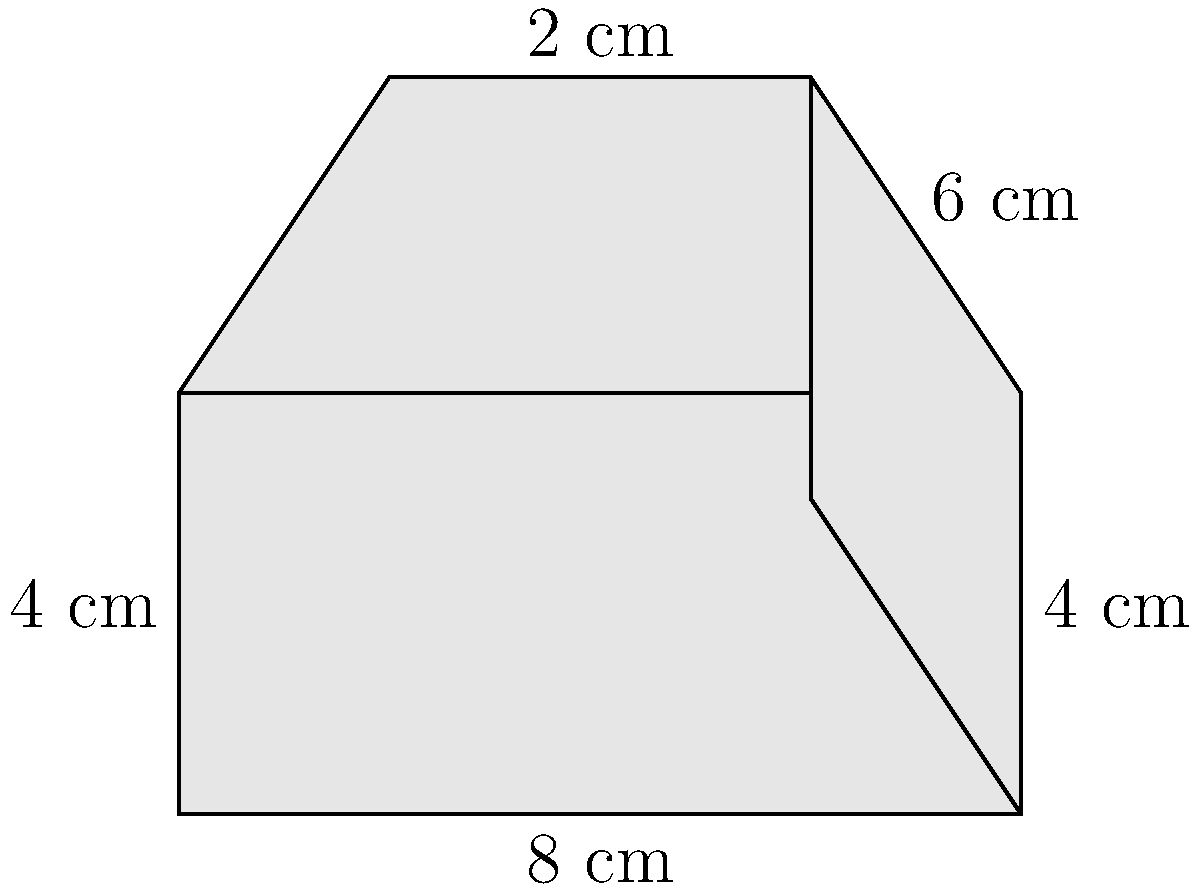You're designing a custom amplifier for your next world tour. The amplifier has an irregular shape as shown in the diagram. The base is a rectangle measuring 8 cm by 4 cm. The top face is a trapezoid with parallel sides of 8 cm and 4 cm, and a height of 3 cm. The front and back are rectangles, while the sides are irregular quadrilaterals. Calculate the total surface area of the amplifier in square centimeters. Let's break this down step-by-step:

1) Base area: 
   $$A_{base} = 8 \times 4 = 32 \text{ cm}^2$$

2) Top area (trapezoid):
   $$A_{top} = \frac{1}{2}(8 + 4) \times 3 = 18 \text{ cm}^2$$

3) Front and back areas (rectangles):
   $$A_{front} = A_{back} = 8 \times 4 = 32 \text{ cm}^2 \text{ each}$$
   $$A_{front+back} = 2 \times 32 = 64 \text{ cm}^2$$

4) Side areas (irregular quadrilaterals):
   We can split each side into a rectangle and a right triangle.
   Rectangle: $4 \times 4 = 16 \text{ cm}^2$
   Triangle: $\frac{1}{2} \times 2 \times 3 = 3 \text{ cm}^2$
   $$A_{oneside} = 16 + 3 = 19 \text{ cm}^2$$
   $$A_{bothsides} = 2 \times 19 = 38 \text{ cm}^2$$

5) Total surface area:
   $$A_{total} = A_{base} + A_{top} + A_{front+back} + A_{bothsides}$$
   $$A_{total} = 32 + 18 + 64 + 38 = 152 \text{ cm}^2$$
Answer: 152 cm² 